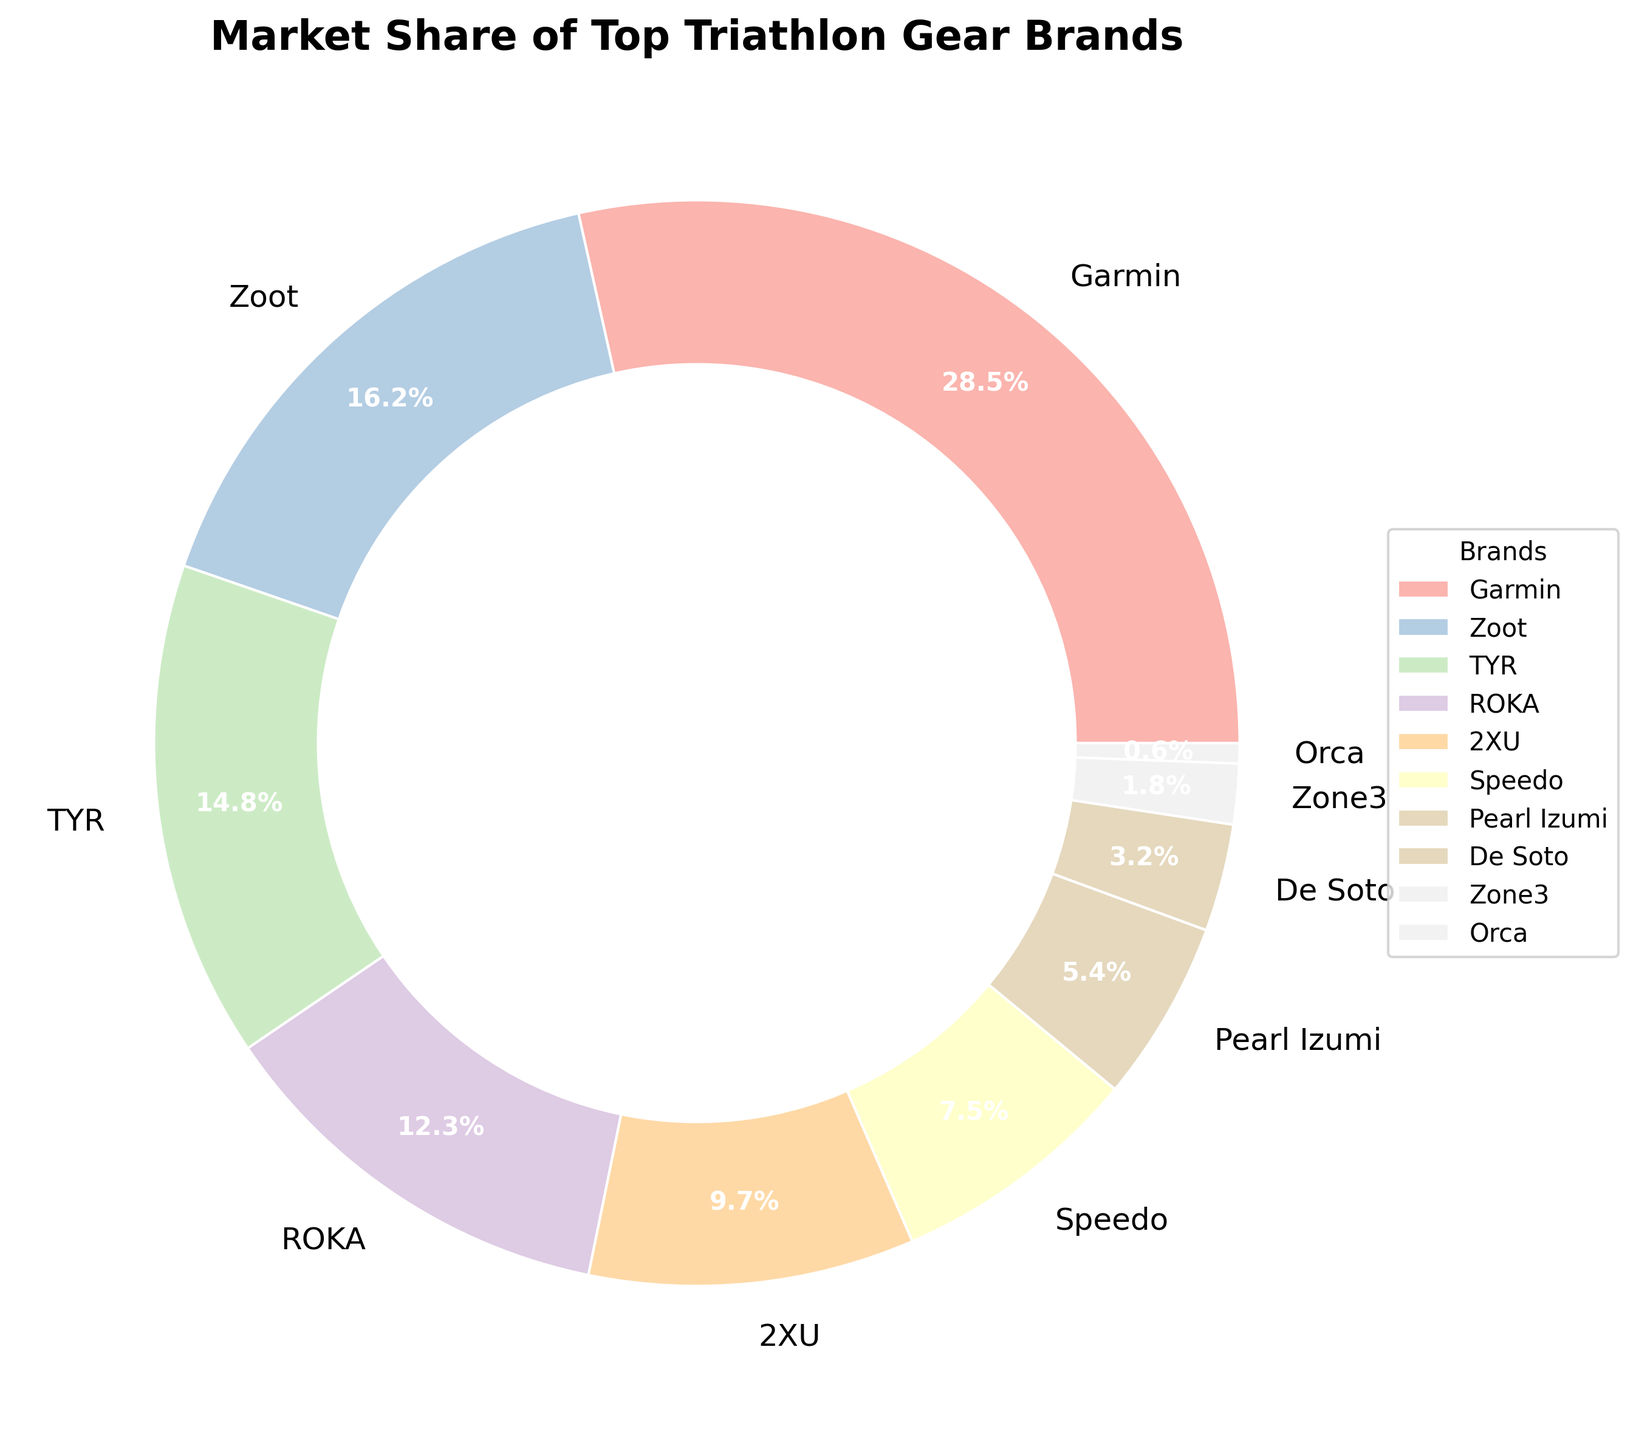Which brand has the highest market share? The brand with the largest slice in the pie chart is Garmin.
Answer: Garmin What is the combined market share of TYR, ROKA, and 2XU? Sum the slices for TYR (14.8%), ROKA (12.3%), and 2XU (9.7%) as shown on the pie chart. 14.8 + 12.3 + 9.7 = 36.8%
Answer: 36.8% How much more market share does Garmin have compared to Speedo? Subtract Speedo's market share (7.5%) from Garmin's (28.5%) as indicated in the pie chart. 28.5 - 7.5 = 21%
Answer: 21% Which brands have a market share less than 5%? Locate the slices in the pie chart representing less than 5%, which are Pearl Izumi (5.4%), De Soto (3.2%), Zone3 (1.8%), and Orca (0.6%).
Answer: De Soto, Zone3, Orca What is the market share of brands other than the top three (Garmin, Zoot, TYR)? Subtract the combined market share of Garmin (28.5%), Zoot (16.2%), and TYR (14.8%) from 100%. 100 - (28.5 + 16.2 + 14.8) = 40.5%
Answer: 40.5% Which specific brands occupy the smallest and largest sections of the pie chart? The largest section corresponds to Garmin (28.5%), and the smallest section corresponds to Orca (0.6%) in the pie chart.
Answer: Garmin, Orca How does the market share of Pearl Izumi compare to that of De Soto? Compare the sizes of the slices for Pearl Izumi (5.4%) and De Soto (3.2%). Pearl Izumi's slice is larger.
Answer: Pearl Izumi has a larger market share than De Soto If you combine the market shares of Zoot and Speedo, would it exceed that of Garmin? Add the market shares of Zoot (16.2%) and Speedo (7.5%) and compare it to Garmin's (28.5%). 16.2 + 7.5 = 23.7, which is less than 28.5.
Answer: No What's the difference between the market shares of 2XU and ROKA? Subtract 2XU's market share (9.7%) from ROKA's (12.3%) as depicted in the pie chart. 12.3 - 9.7 = 2.6
Answer: 2.6% What is the average market share of the brands with more than 10%? Identify brands with more than 10%: Garmin (28.5%), Zoot (16.2%), TYR (14.8%), ROKA (12.3%). Calculate their average: (28.5 + 16.2 + 14.8 + 12.3) / 4 = 17.95
Answer: 17.95% 